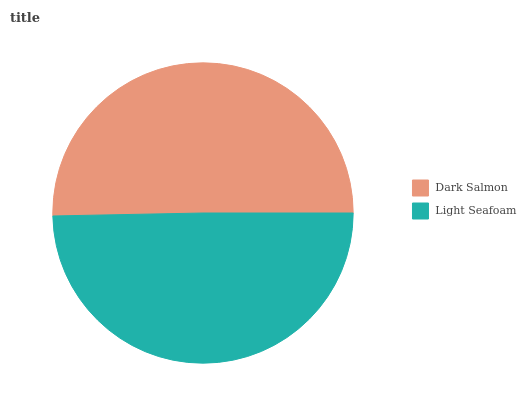Is Light Seafoam the minimum?
Answer yes or no. Yes. Is Dark Salmon the maximum?
Answer yes or no. Yes. Is Light Seafoam the maximum?
Answer yes or no. No. Is Dark Salmon greater than Light Seafoam?
Answer yes or no. Yes. Is Light Seafoam less than Dark Salmon?
Answer yes or no. Yes. Is Light Seafoam greater than Dark Salmon?
Answer yes or no. No. Is Dark Salmon less than Light Seafoam?
Answer yes or no. No. Is Dark Salmon the high median?
Answer yes or no. Yes. Is Light Seafoam the low median?
Answer yes or no. Yes. Is Light Seafoam the high median?
Answer yes or no. No. Is Dark Salmon the low median?
Answer yes or no. No. 